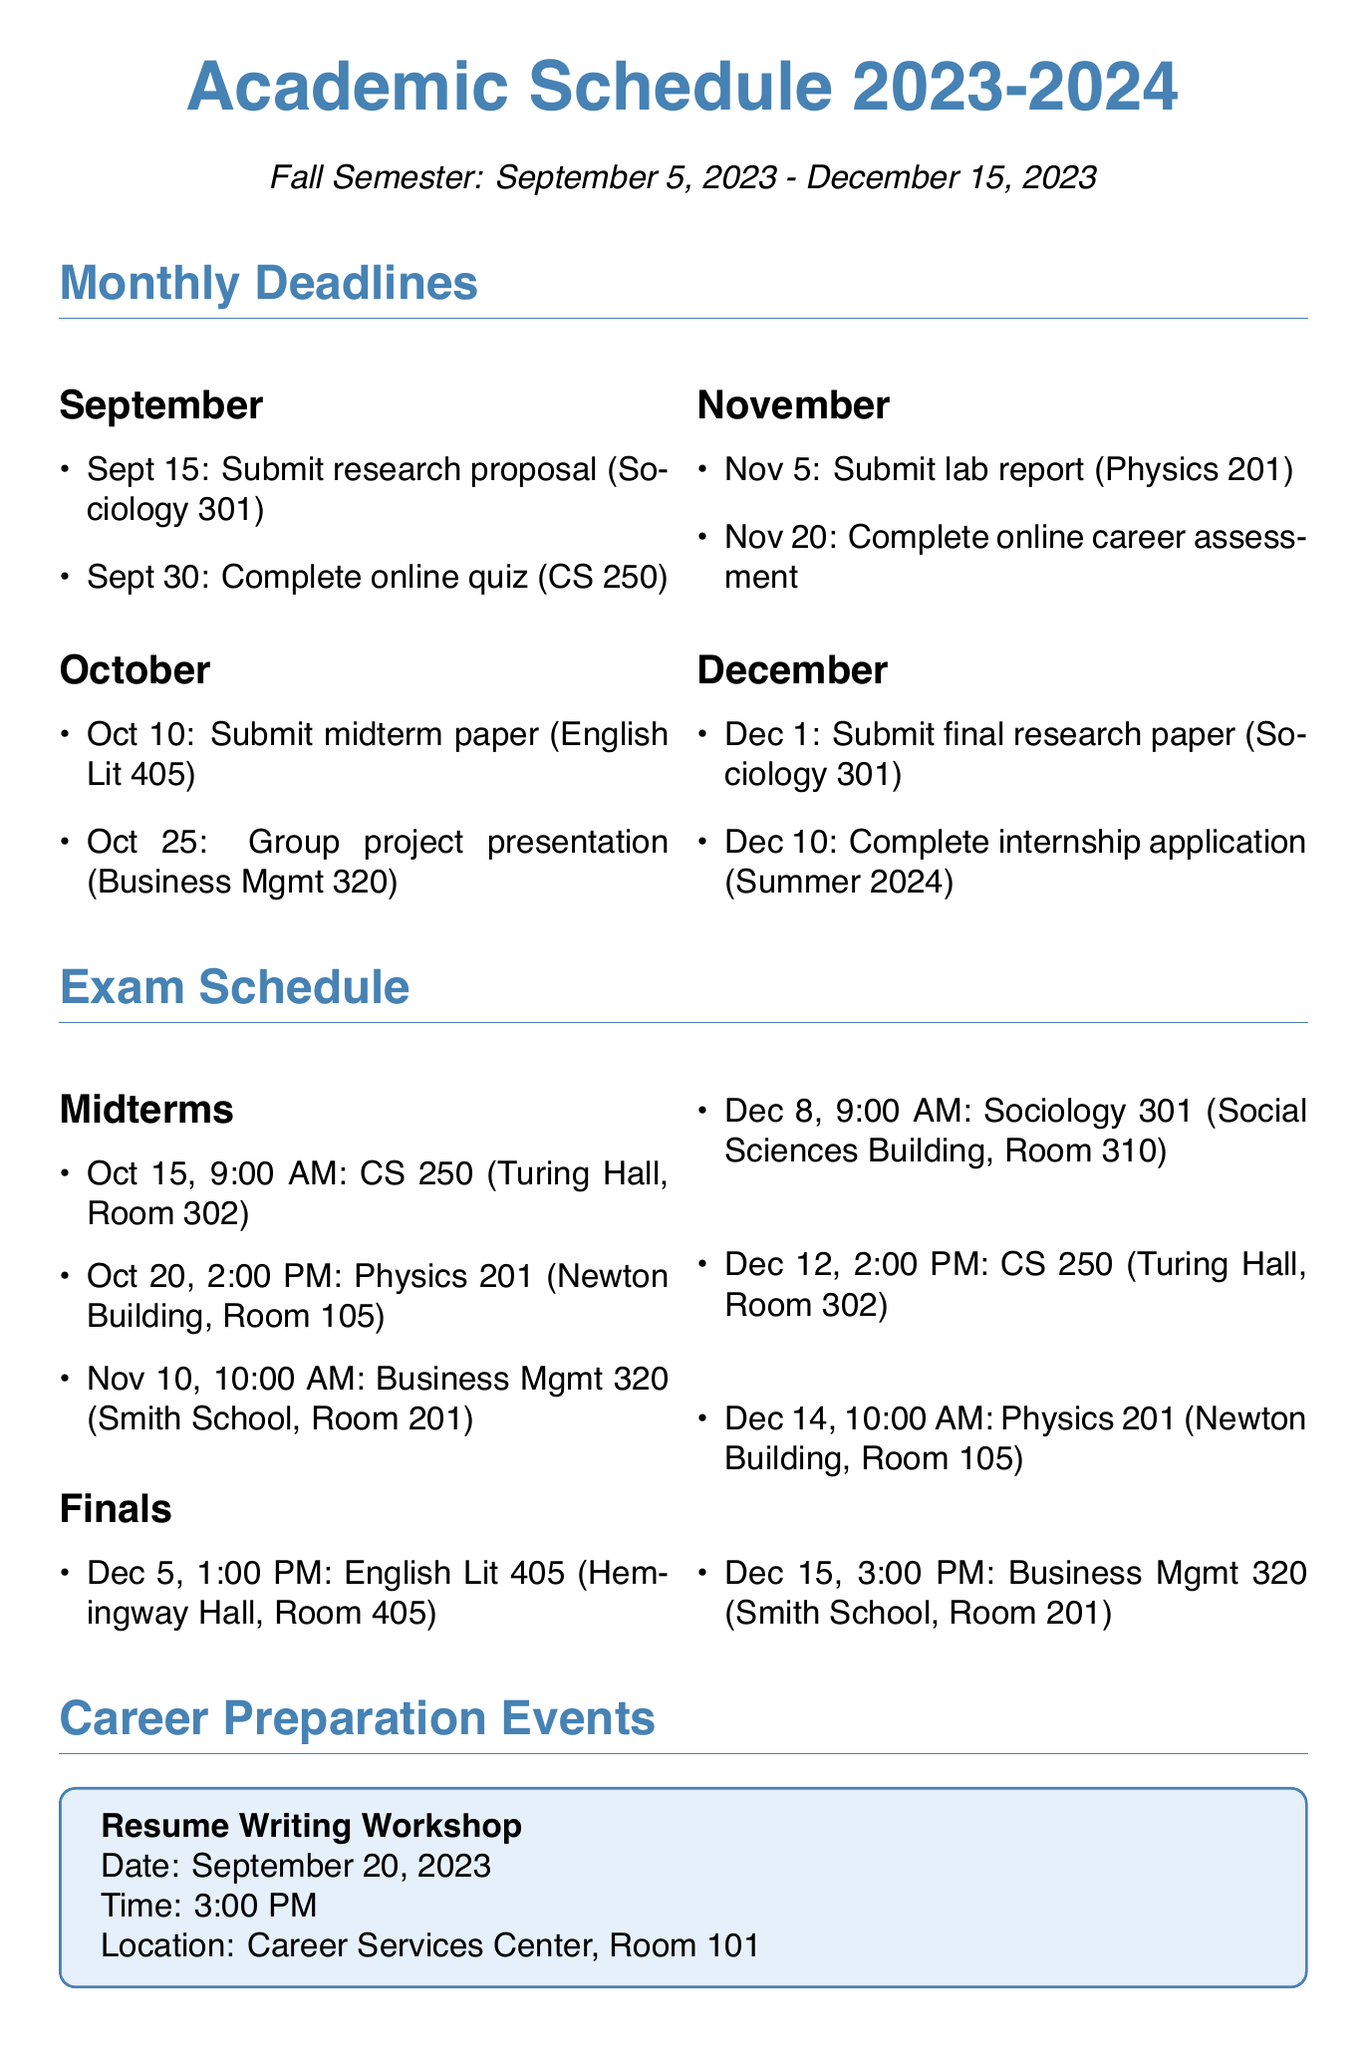What is the end date of the Fall Semester? The end date of the Fall Semester is specified in the document under semesters, which is December 15, 2023.
Answer: December 15, 2023 When is the group project presentation for Business Management 320 due? The document lists this deadline in the October section, which is October 25, 2023.
Answer: October 25, 2023 How many midterm exams are scheduled? The number of midterm exams can be counted in the exam schedule section, which lists three midterms.
Answer: 3 What time is the Sociology 301 final exam? The time for the Sociology 301 final exam is mentioned under the final exams section, specifically noted as 9:00 AM.
Answer: 9:00 AM What event occurs on November 15, 2023? The document mentions a specific career preparation event on that date, which is the Mock Interview Day.
Answer: Mock Interview Day Which course has a study group every Tuesday? The document provides details about study groups, including that Computer Science 250 meets every Tuesday.
Answer: Computer Science 250 What is the location for the resume writing workshop? The location for this workshop is included in the details of the event, which is Career Services Center, Room 101.
Answer: Career Services Center, Room 101 When do the study groups for Physics 201 occur? The day and time for the Physics 201 study group are explicitly stated in the document as Every Thursday at 6:00 PM - 8:00 PM.
Answer: Every Thursday, 6:00 PM - 8:00 PM 